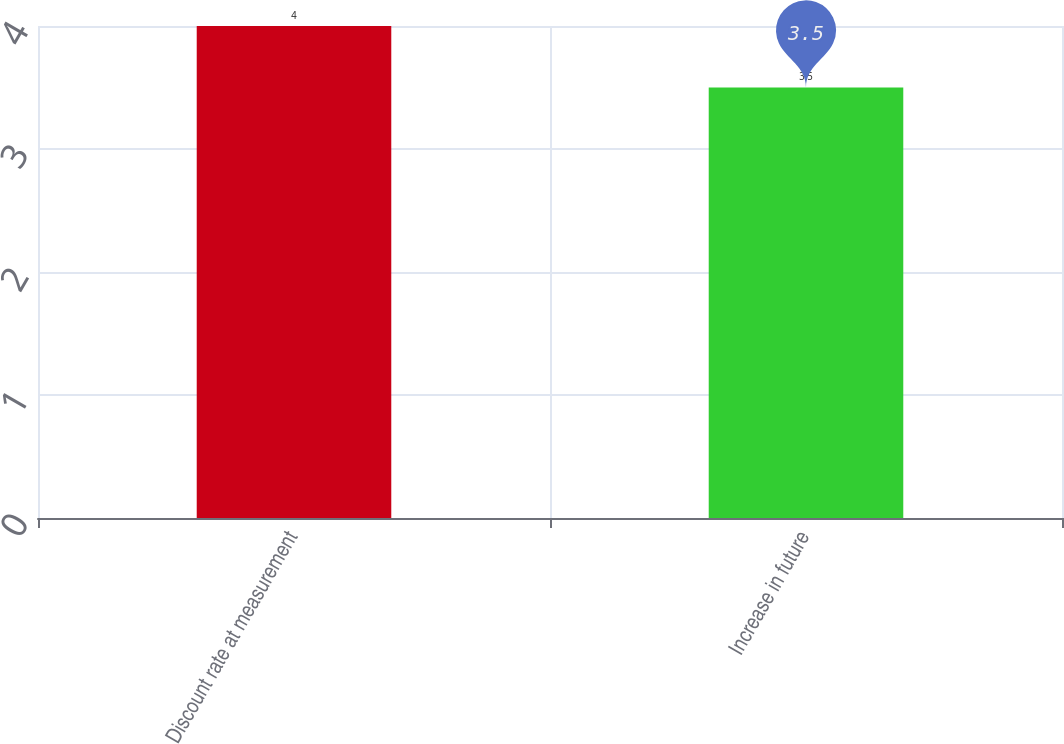Convert chart to OTSL. <chart><loc_0><loc_0><loc_500><loc_500><bar_chart><fcel>Discount rate at measurement<fcel>Increase in future<nl><fcel>4<fcel>3.5<nl></chart> 